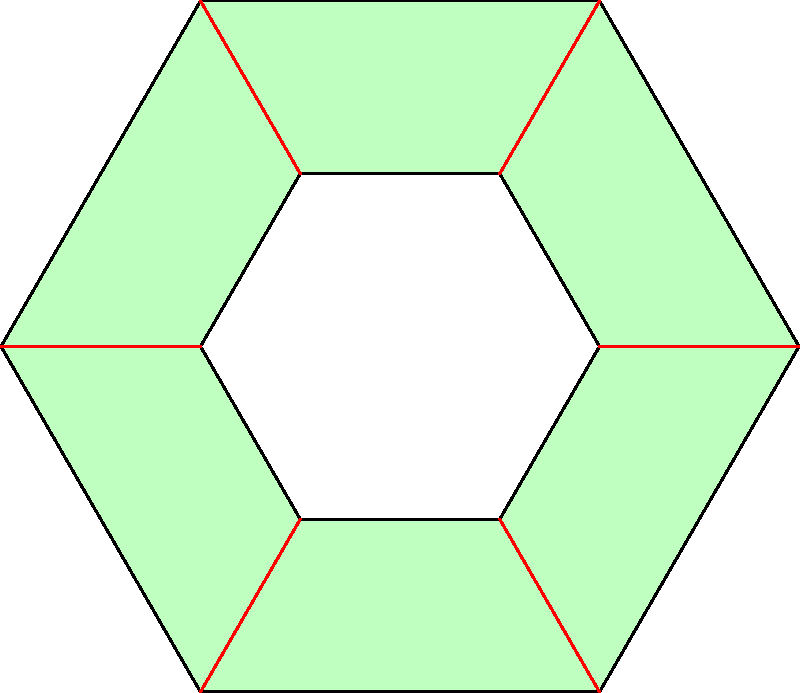In many indigenous Brazilian artworks, geometric patterns play a significant role. The figure above represents a common motif found in traditional body paintings and crafts. How many lines of symmetry does this pattern have? To determine the number of lines of symmetry in this pattern, let's follow these steps:

1. Identify the shape: The pattern consists of two concentric regular hexagons with lines connecting their corresponding vertices.

2. Understand symmetry in a regular hexagon:
   - A regular hexagon has 6 lines of symmetry.
   - These lines pass through:
     a) Opposite vertices (3 lines)
     b) Midpoints of opposite sides (3 lines)

3. Analyze the given pattern:
   - The additional elements (inner hexagon and connecting lines) maintain the symmetry of the outer hexagon.
   - Each line that was a line of symmetry for the regular hexagon remains a line of symmetry for this entire pattern.

4. Count the lines of symmetry:
   - 3 lines passing through opposite vertices
   - 3 lines passing through midpoints of opposite sides
   - Total: 3 + 3 = 6 lines of symmetry

Therefore, this pattern, inspired by indigenous Brazilian art, has 6 lines of symmetry, preserving the symmetrical nature of the regular hexagon it's based on.
Answer: 6 lines of symmetry 